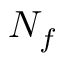<formula> <loc_0><loc_0><loc_500><loc_500>N _ { f }</formula> 